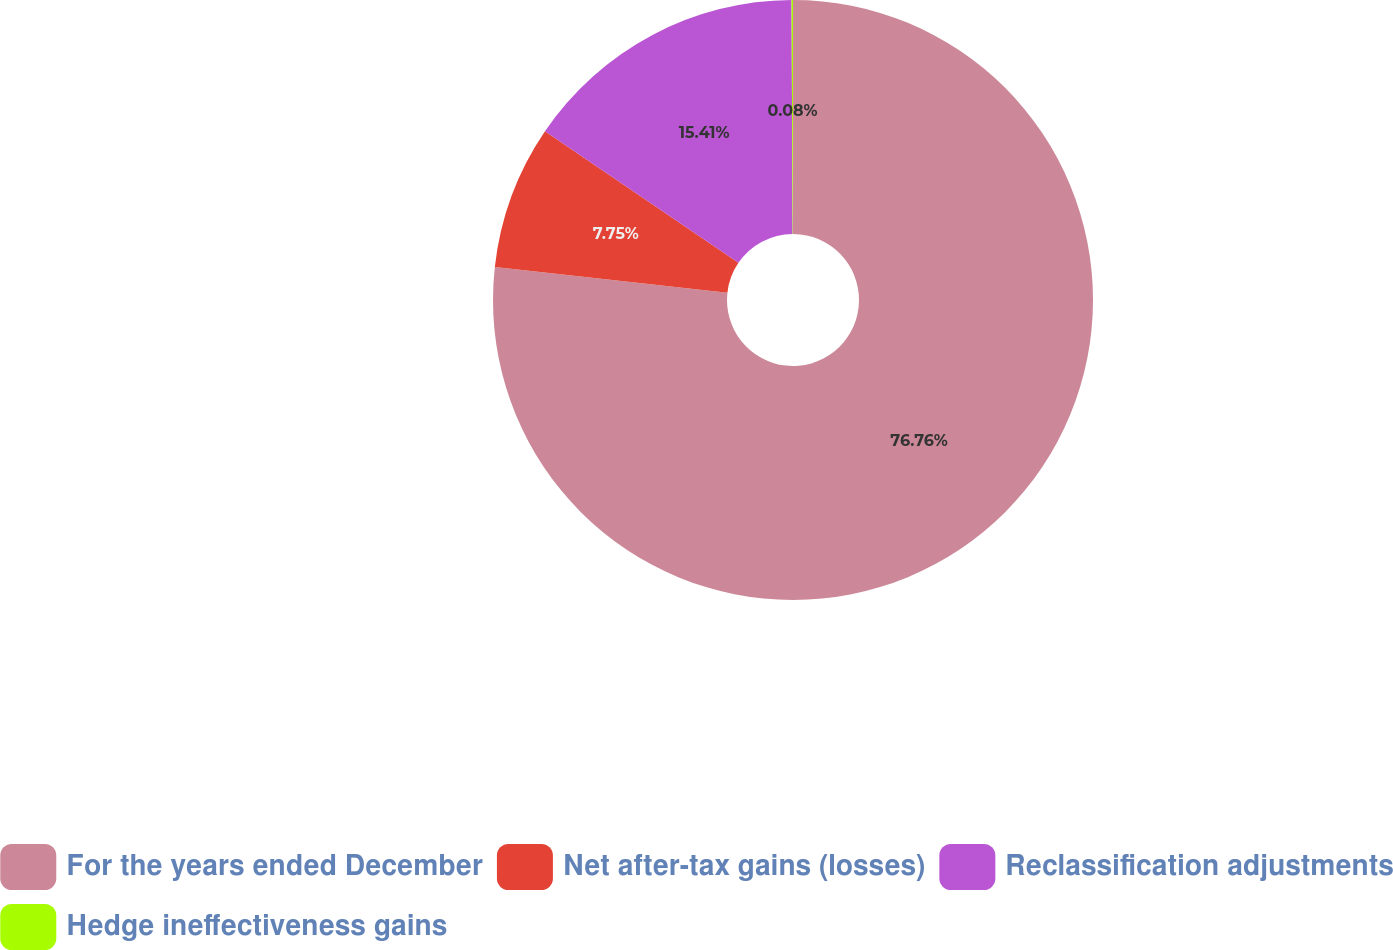Convert chart to OTSL. <chart><loc_0><loc_0><loc_500><loc_500><pie_chart><fcel>For the years ended December<fcel>Net after-tax gains (losses)<fcel>Reclassification adjustments<fcel>Hedge ineffectiveness gains<nl><fcel>76.76%<fcel>7.75%<fcel>15.41%<fcel>0.08%<nl></chart> 